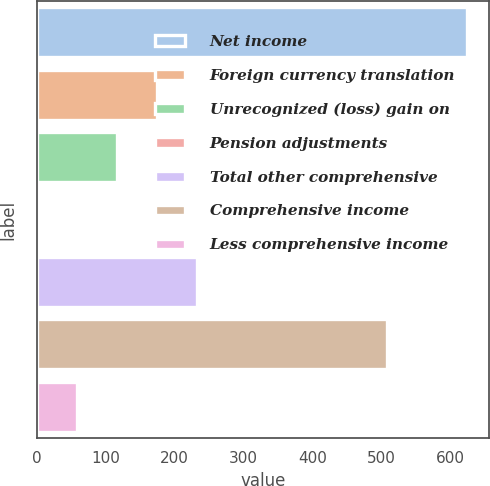Convert chart. <chart><loc_0><loc_0><loc_500><loc_500><bar_chart><fcel>Net income<fcel>Foreign currency translation<fcel>Unrecognized (loss) gain on<fcel>Pension adjustments<fcel>Total other comprehensive<fcel>Comprehensive income<fcel>Less comprehensive income<nl><fcel>625.2<fcel>175.3<fcel>117.2<fcel>1<fcel>233.4<fcel>509<fcel>59.1<nl></chart> 